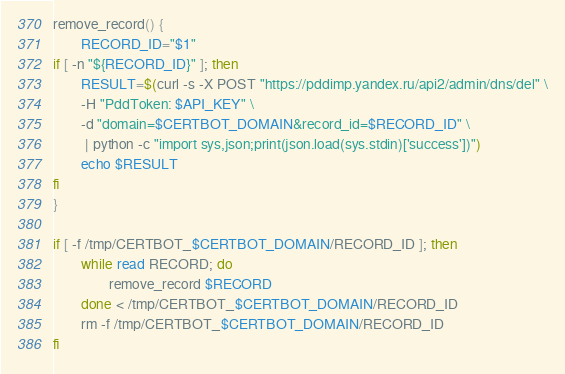<code> <loc_0><loc_0><loc_500><loc_500><_Bash_>remove_record() {
        RECORD_ID="$1"
if [ -n "${RECORD_ID}" ]; then
        RESULT=$(curl -s -X POST "https://pddimp.yandex.ru/api2/admin/dns/del" \
        -H "PddToken: $API_KEY" \
        -d "domain=$CERTBOT_DOMAIN&record_id=$RECORD_ID" \
         | python -c "import sys,json;print(json.load(sys.stdin)['success'])")
        echo $RESULT
fi
}

if [ -f /tmp/CERTBOT_$CERTBOT_DOMAIN/RECORD_ID ]; then
        while read RECORD; do
                remove_record $RECORD
        done < /tmp/CERTBOT_$CERTBOT_DOMAIN/RECORD_ID
        rm -f /tmp/CERTBOT_$CERTBOT_DOMAIN/RECORD_ID
fi</code> 